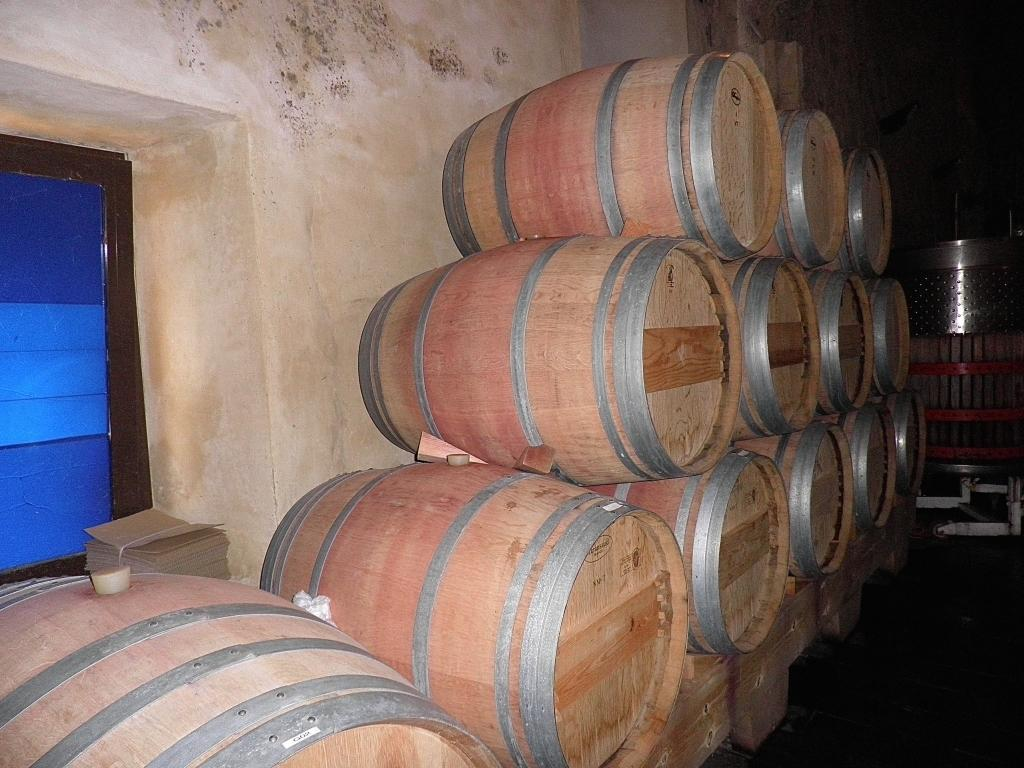What musical instruments are present in the image? There are drums in the image. Where are the drums located in relation to other objects? The drums are beside a wall. What architectural feature can be seen on the left side of the image? There is a window on the left side of the image. What type of watch is the drummer wearing in the image? There is no drummer or watch present in the image; it only features drums beside a wall and a window on the left side. 